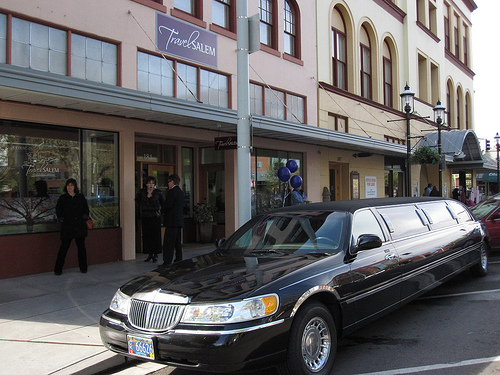<image>
Is the limo behind the balloons? No. The limo is not behind the balloons. From this viewpoint, the limo appears to be positioned elsewhere in the scene. 